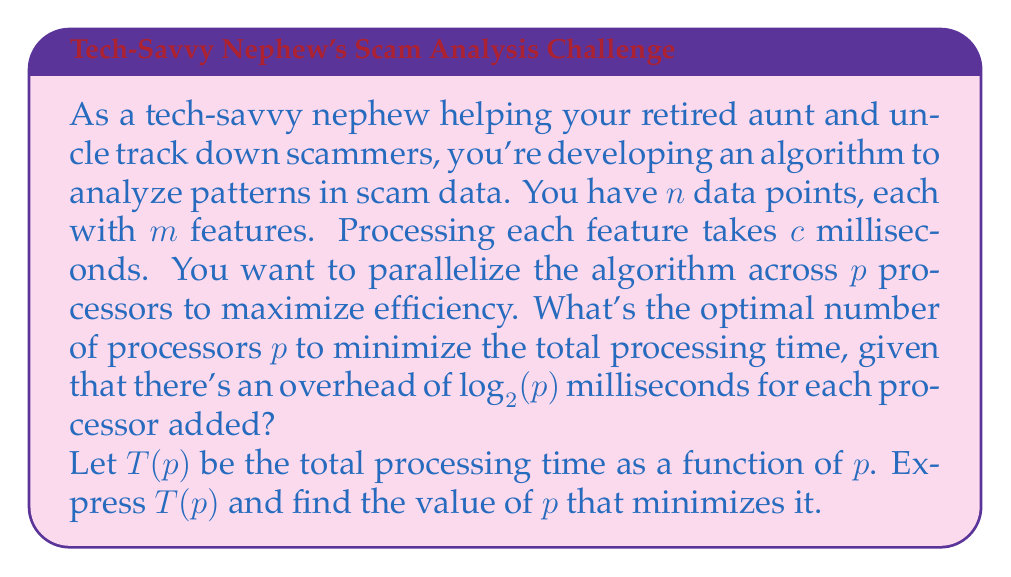Solve this math problem. To solve this optimization problem, we'll follow these steps:

1. Express the total processing time $T(p)$ as a function of $p$.
2. Find the derivative of $T(p)$ with respect to $p$.
3. Set the derivative to zero and solve for $p$.
4. Verify that this critical point is a minimum.

Step 1: Express $T(p)$

The total processing time consists of two parts:
a) Time to process the data: $\frac{nmcp}{p} = \frac{nmc}{p}$
b) Overhead time for adding processors: $p \log_2(p)$

Thus, $T(p) = \frac{nmc}{p} + p \log_2(p)$

Step 2: Find the derivative

$$\frac{dT}{dp} = -\frac{nmc}{p^2} + \log_2(p) + \frac{p}{\ln(2)}$$

Step 3: Set the derivative to zero and solve

$$-\frac{nmc}{p^2} + \log_2(p) + \frac{p}{\ln(2)} = 0$$

This equation cannot be solved analytically. We need to use numerical methods or Lambert W function to find the exact solution.

Step 4: Verify the critical point

The second derivative is:

$$\frac{d^2T}{dp^2} = \frac{2nmc}{p^3} + \frac{1}{p\ln(2)} + \frac{1}{\ln(2)}$$

This is always positive for $p > 0$, confirming that the critical point is a minimum.

In practice, since $p$ must be an integer, we would compute $T(p)$ for the floor and ceiling of the calculated optimal $p$, and choose the one that gives the smaller $T(p)$.
Answer: The optimal number of processors $p$ minimizes the function:

$$T(p) = \frac{nmc}{p} + p \log_2(p)$$

This can be found numerically by solving:

$$-\frac{nmc}{p^2} + \log_2(p) + \frac{p}{\ln(2)} = 0$$

The exact solution depends on the values of $n$, $m$, and $c$. In practice, compute $T(p)$ for the floor and ceiling of the calculated optimal $p$, and choose the integer $p$ that gives the smaller $T(p)$. 